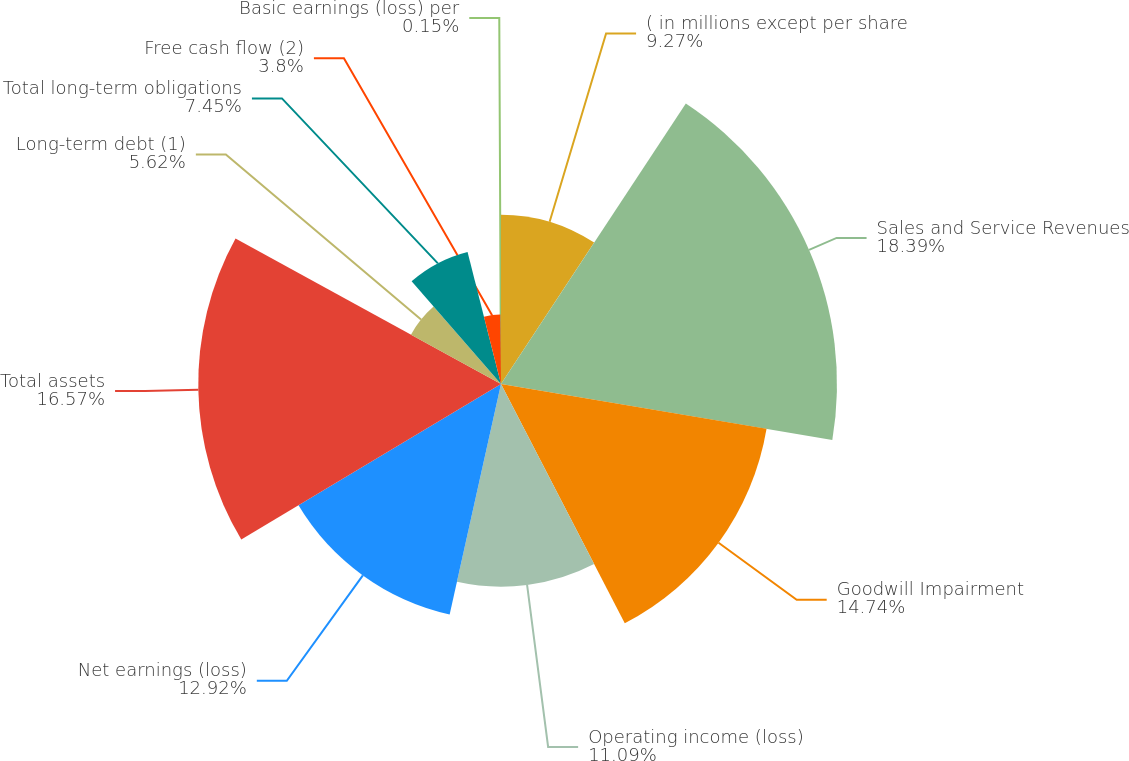<chart> <loc_0><loc_0><loc_500><loc_500><pie_chart><fcel>( in millions except per share<fcel>Sales and Service Revenues<fcel>Goodwill Impairment<fcel>Operating income (loss)<fcel>Net earnings (loss)<fcel>Total assets<fcel>Long-term debt (1)<fcel>Total long-term obligations<fcel>Free cash flow (2)<fcel>Basic earnings (loss) per<nl><fcel>9.27%<fcel>18.39%<fcel>14.74%<fcel>11.09%<fcel>12.92%<fcel>16.57%<fcel>5.62%<fcel>7.45%<fcel>3.8%<fcel>0.15%<nl></chart> 